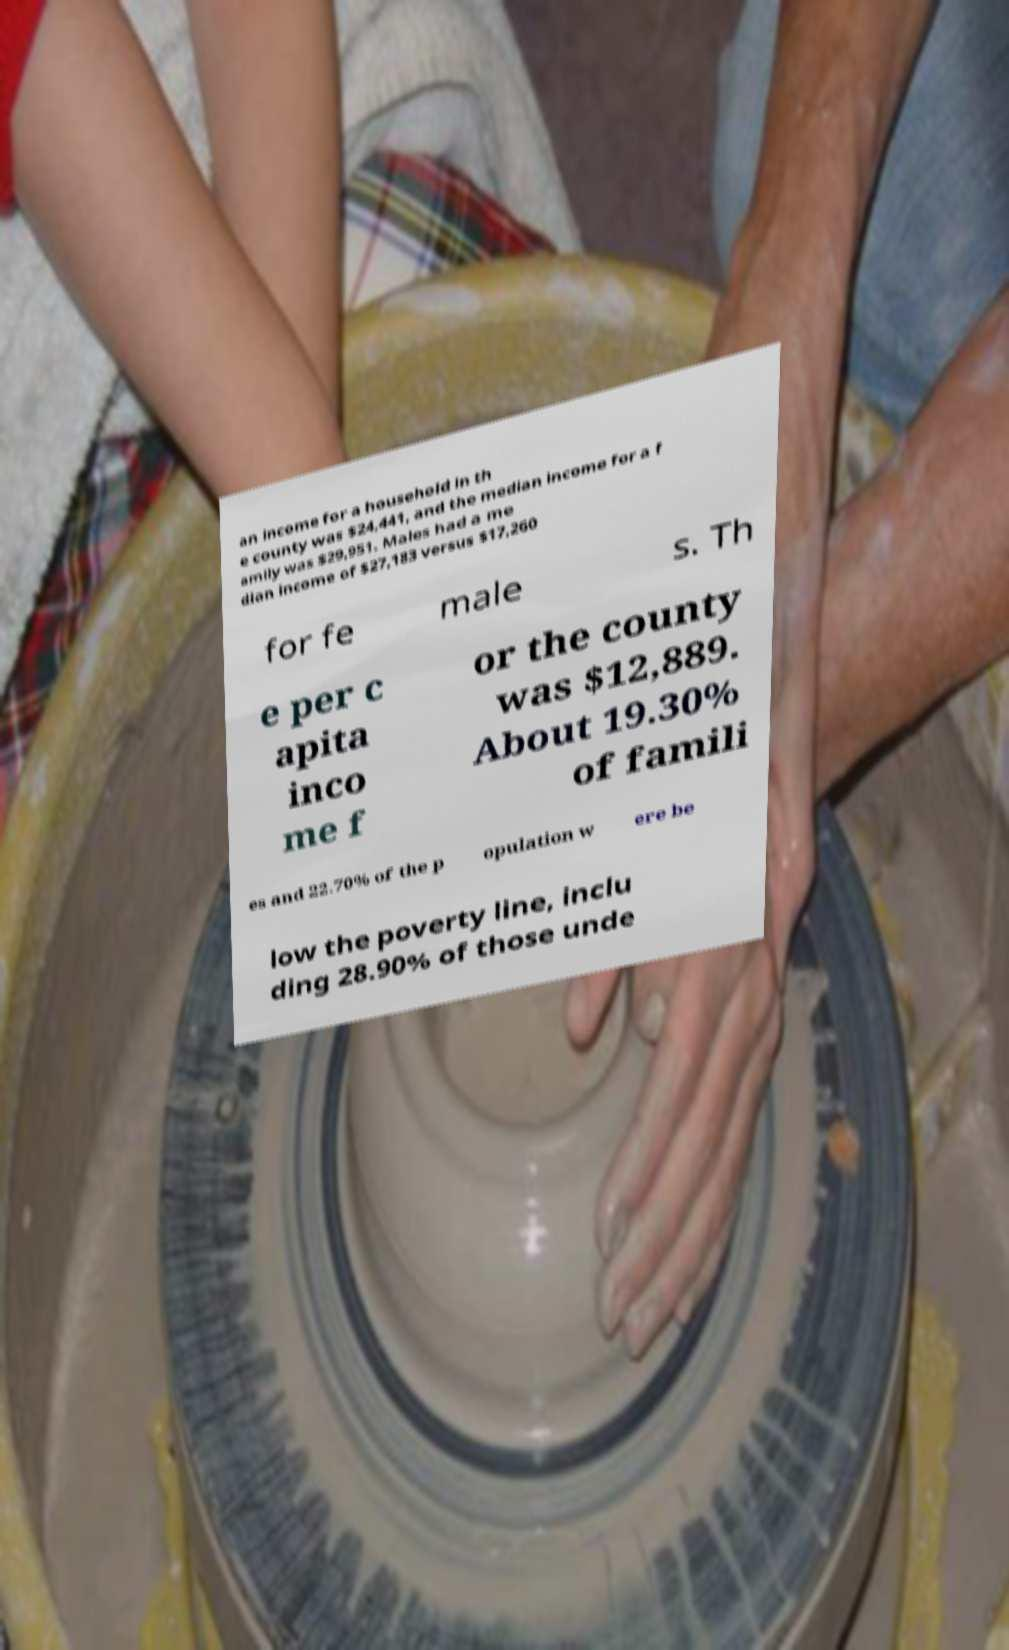There's text embedded in this image that I need extracted. Can you transcribe it verbatim? an income for a household in th e county was $24,441, and the median income for a f amily was $29,951. Males had a me dian income of $27,183 versus $17,260 for fe male s. Th e per c apita inco me f or the county was $12,889. About 19.30% of famili es and 22.70% of the p opulation w ere be low the poverty line, inclu ding 28.90% of those unde 